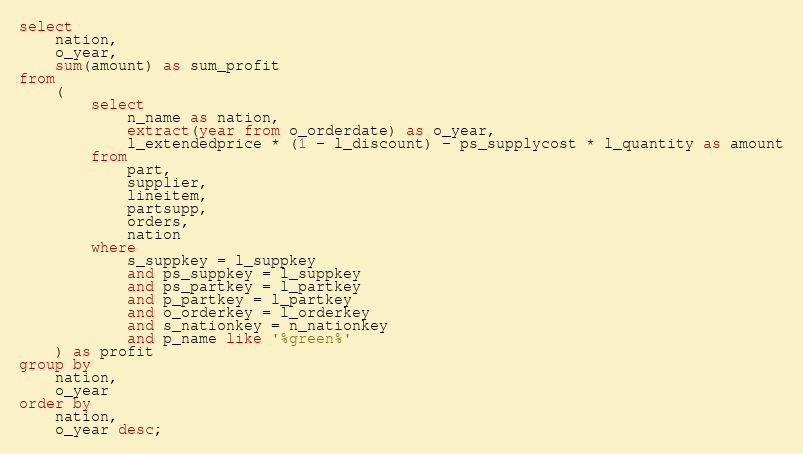Convert code to text. <code><loc_0><loc_0><loc_500><loc_500><_SQL_>select
	nation,
	o_year,
	sum(amount) as sum_profit
from
	(
		select
			n_name as nation,
			extract(year from o_orderdate) as o_year,
			l_extendedprice * (1 - l_discount) - ps_supplycost * l_quantity as amount
		from
			part,
			supplier,
			lineitem,
			partsupp,
			orders,
			nation
		where
			s_suppkey = l_suppkey
			and ps_suppkey = l_suppkey
			and ps_partkey = l_partkey
			and p_partkey = l_partkey
			and o_orderkey = l_orderkey
			and s_nationkey = n_nationkey
			and p_name like '%green%'
	) as profit
group by
	nation,
	o_year
order by
	nation,
	o_year desc;
</code> 